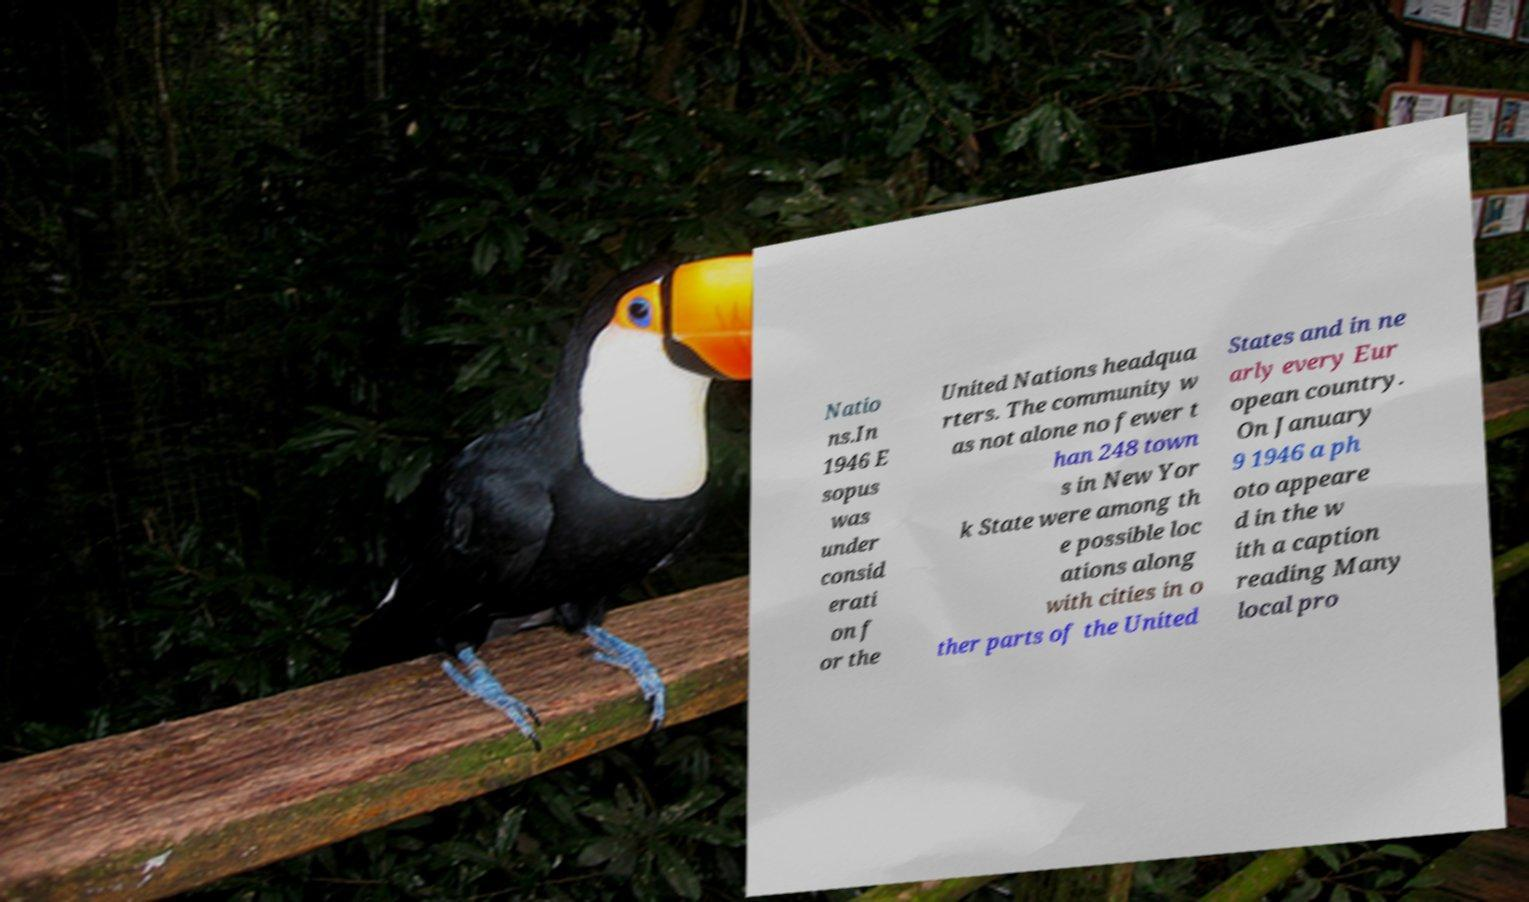Could you assist in decoding the text presented in this image and type it out clearly? Natio ns.In 1946 E sopus was under consid erati on f or the United Nations headqua rters. The community w as not alone no fewer t han 248 town s in New Yor k State were among th e possible loc ations along with cities in o ther parts of the United States and in ne arly every Eur opean country. On January 9 1946 a ph oto appeare d in the w ith a caption reading Many local pro 